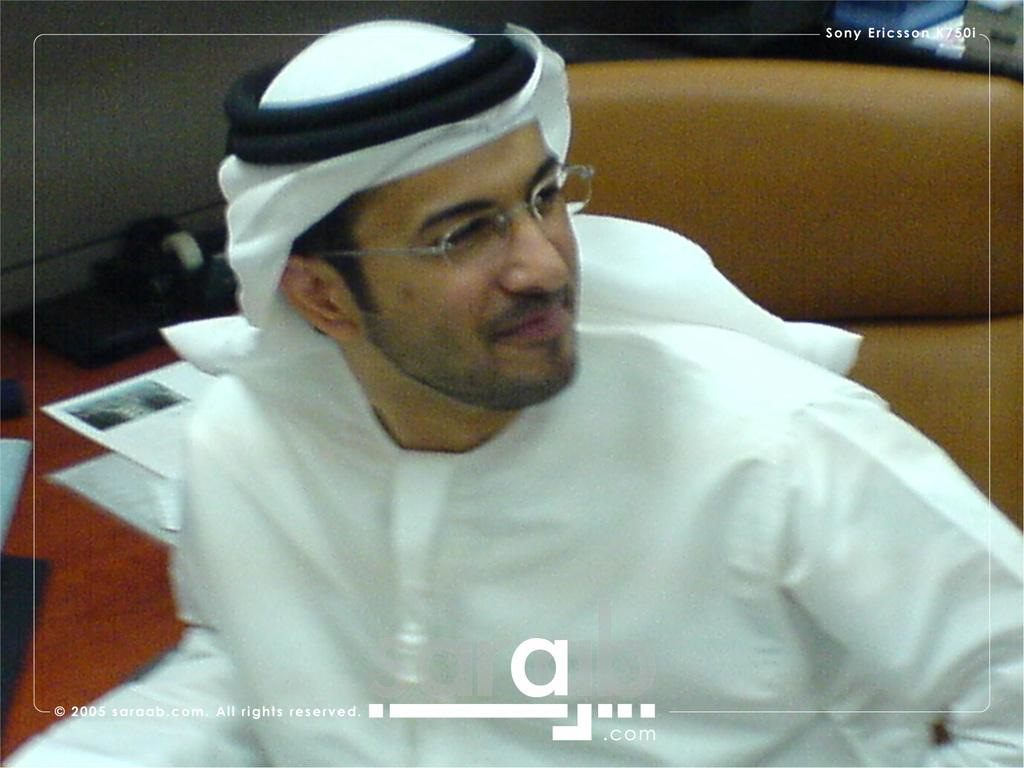Who or what is in the image? There is a person in the image. What is the person wearing? The person is wearing a white dress. What can be seen on the table in the image? There is a brown color table in the image, and papers are present on the table. What type of butter is being used to write on the papers in the image? There is no butter present in the image, and the papers do not show any signs of being written on. 